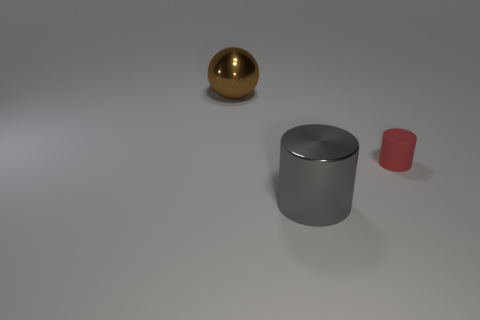Is there anything else that is the same shape as the brown object?
Offer a very short reply. No. Is there any other thing that has the same size as the red object?
Your answer should be compact. No. Is there a matte thing that is right of the large thing that is right of the metal sphere?
Offer a very short reply. Yes. Does the red cylinder have the same size as the metal object on the right side of the big brown sphere?
Your answer should be compact. No. There is a cylinder that is behind the large object in front of the tiny red object; are there any gray shiny cylinders that are behind it?
Your response must be concise. No. There is a big thing that is to the right of the metallic ball; what is it made of?
Your answer should be compact. Metal. Is the red matte object the same size as the brown metal object?
Your answer should be compact. No. The thing that is behind the gray object and to the left of the red cylinder is what color?
Offer a terse response. Brown. There is a big object that is made of the same material as the brown ball; what is its shape?
Offer a terse response. Cylinder. How many metallic things are in front of the large sphere and behind the tiny red matte thing?
Give a very brief answer. 0. 